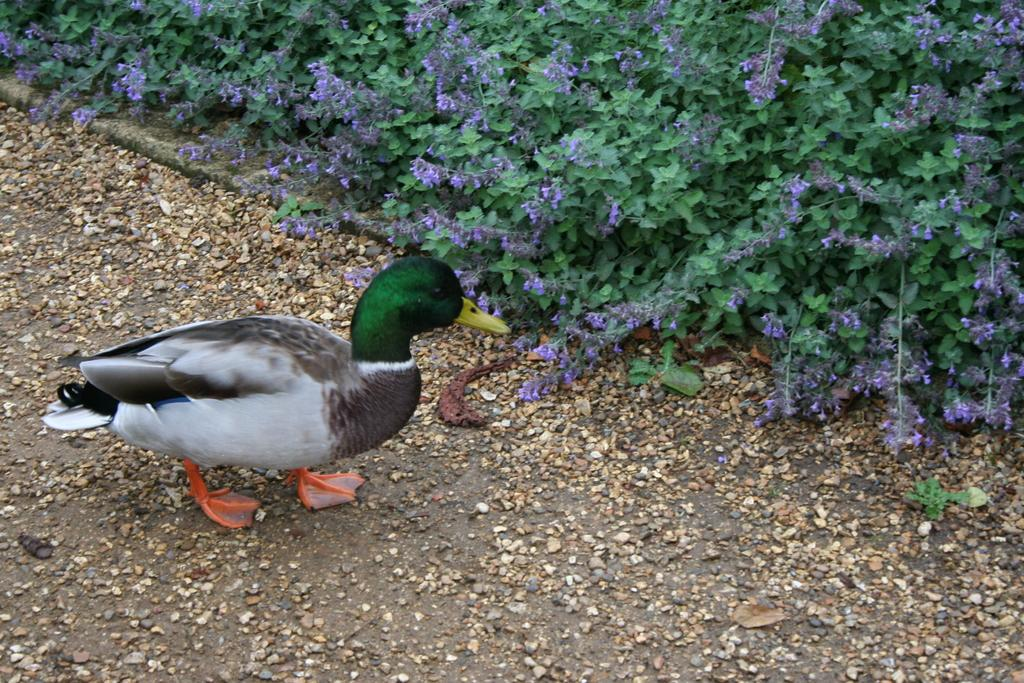What animal is located on the left side of the image? There is a duck on the left side of the image. What type of vegetation is present at the top of the image? There are plants and flowers at the top of the image. What type of terrain is visible at the bottom of the image? There is sand and small stones at the bottom of the image. Where is the faucet located in the image? There is no faucet present in the image. What type of debt is being discussed in the image? There is no mention of debt in the image. 